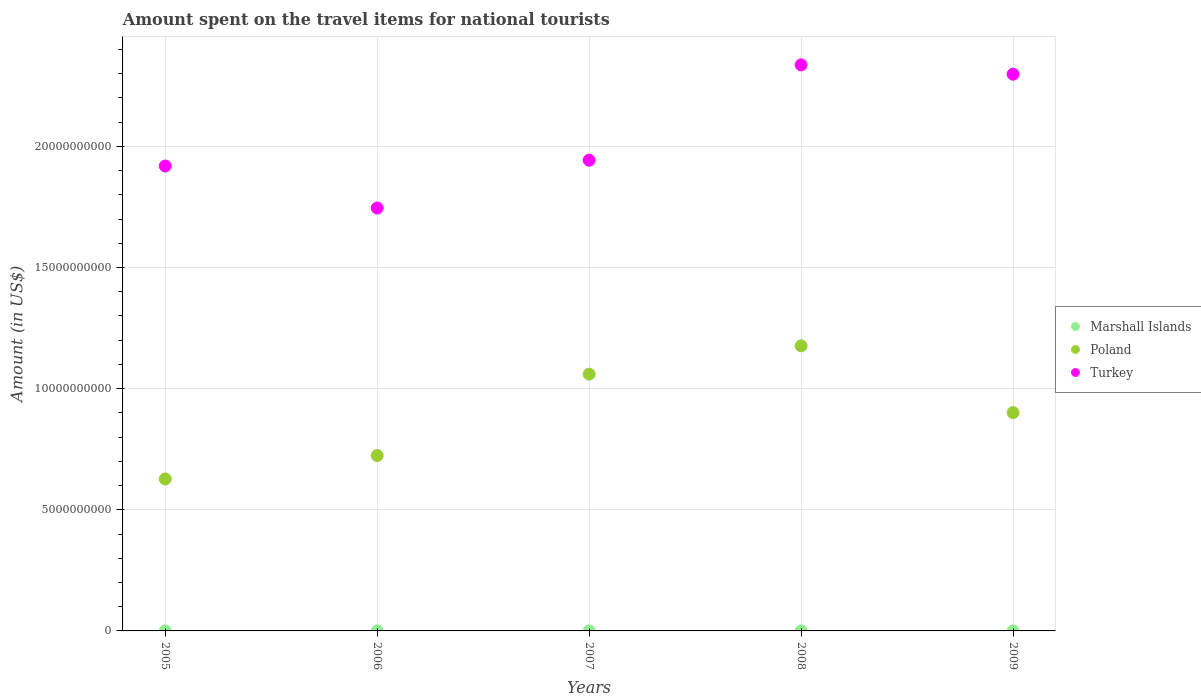How many different coloured dotlines are there?
Give a very brief answer. 3. Is the number of dotlines equal to the number of legend labels?
Make the answer very short. Yes. What is the amount spent on the travel items for national tourists in Marshall Islands in 2007?
Make the answer very short. 2.88e+06. Across all years, what is the maximum amount spent on the travel items for national tourists in Marshall Islands?
Offer a very short reply. 3.20e+06. Across all years, what is the minimum amount spent on the travel items for national tourists in Turkey?
Provide a succinct answer. 1.75e+1. What is the total amount spent on the travel items for national tourists in Turkey in the graph?
Provide a succinct answer. 1.02e+11. What is the difference between the amount spent on the travel items for national tourists in Poland in 2006 and that in 2009?
Offer a very short reply. -1.77e+09. What is the difference between the amount spent on the travel items for national tourists in Turkey in 2008 and the amount spent on the travel items for national tourists in Marshall Islands in 2009?
Provide a succinct answer. 2.34e+1. What is the average amount spent on the travel items for national tourists in Marshall Islands per year?
Keep it short and to the point. 2.94e+06. In the year 2008, what is the difference between the amount spent on the travel items for national tourists in Poland and amount spent on the travel items for national tourists in Turkey?
Offer a very short reply. -1.16e+1. In how many years, is the amount spent on the travel items for national tourists in Marshall Islands greater than 18000000000 US$?
Your answer should be compact. 0. What is the ratio of the amount spent on the travel items for national tourists in Poland in 2005 to that in 2008?
Offer a very short reply. 0.53. Is the amount spent on the travel items for national tourists in Poland in 2005 less than that in 2006?
Provide a short and direct response. Yes. What is the difference between the highest and the second highest amount spent on the travel items for national tourists in Marshall Islands?
Give a very brief answer. 1.00e+05. What is the difference between the highest and the lowest amount spent on the travel items for national tourists in Poland?
Provide a succinct answer. 5.49e+09. Does the amount spent on the travel items for national tourists in Marshall Islands monotonically increase over the years?
Keep it short and to the point. No. Is the amount spent on the travel items for national tourists in Marshall Islands strictly greater than the amount spent on the travel items for national tourists in Poland over the years?
Make the answer very short. No. What is the difference between two consecutive major ticks on the Y-axis?
Ensure brevity in your answer.  5.00e+09. Are the values on the major ticks of Y-axis written in scientific E-notation?
Make the answer very short. No. Does the graph contain any zero values?
Provide a short and direct response. No. Where does the legend appear in the graph?
Provide a succinct answer. Center right. How many legend labels are there?
Your answer should be compact. 3. How are the legend labels stacked?
Keep it short and to the point. Vertical. What is the title of the graph?
Ensure brevity in your answer.  Amount spent on the travel items for national tourists. What is the label or title of the Y-axis?
Your response must be concise. Amount (in US$). What is the Amount (in US$) of Marshall Islands in 2005?
Offer a very short reply. 3.20e+06. What is the Amount (in US$) in Poland in 2005?
Ensure brevity in your answer.  6.27e+09. What is the Amount (in US$) in Turkey in 2005?
Your answer should be very brief. 1.92e+1. What is the Amount (in US$) in Marshall Islands in 2006?
Make the answer very short. 3.10e+06. What is the Amount (in US$) in Poland in 2006?
Your response must be concise. 7.24e+09. What is the Amount (in US$) of Turkey in 2006?
Offer a very short reply. 1.75e+1. What is the Amount (in US$) in Marshall Islands in 2007?
Provide a succinct answer. 2.88e+06. What is the Amount (in US$) of Poland in 2007?
Keep it short and to the point. 1.06e+1. What is the Amount (in US$) of Turkey in 2007?
Your response must be concise. 1.94e+1. What is the Amount (in US$) of Marshall Islands in 2008?
Keep it short and to the point. 2.60e+06. What is the Amount (in US$) in Poland in 2008?
Offer a terse response. 1.18e+1. What is the Amount (in US$) in Turkey in 2008?
Offer a very short reply. 2.34e+1. What is the Amount (in US$) in Marshall Islands in 2009?
Offer a very short reply. 2.90e+06. What is the Amount (in US$) of Poland in 2009?
Provide a short and direct response. 9.01e+09. What is the Amount (in US$) of Turkey in 2009?
Your response must be concise. 2.30e+1. Across all years, what is the maximum Amount (in US$) of Marshall Islands?
Provide a succinct answer. 3.20e+06. Across all years, what is the maximum Amount (in US$) of Poland?
Your answer should be compact. 1.18e+1. Across all years, what is the maximum Amount (in US$) of Turkey?
Offer a very short reply. 2.34e+1. Across all years, what is the minimum Amount (in US$) of Marshall Islands?
Provide a succinct answer. 2.60e+06. Across all years, what is the minimum Amount (in US$) of Poland?
Your answer should be very brief. 6.27e+09. Across all years, what is the minimum Amount (in US$) of Turkey?
Provide a succinct answer. 1.75e+1. What is the total Amount (in US$) of Marshall Islands in the graph?
Provide a short and direct response. 1.47e+07. What is the total Amount (in US$) in Poland in the graph?
Make the answer very short. 4.49e+1. What is the total Amount (in US$) of Turkey in the graph?
Your answer should be compact. 1.02e+11. What is the difference between the Amount (in US$) of Poland in 2005 and that in 2006?
Your answer should be compact. -9.65e+08. What is the difference between the Amount (in US$) of Turkey in 2005 and that in 2006?
Provide a short and direct response. 1.73e+09. What is the difference between the Amount (in US$) in Marshall Islands in 2005 and that in 2007?
Keep it short and to the point. 3.20e+05. What is the difference between the Amount (in US$) of Poland in 2005 and that in 2007?
Your response must be concise. -4.32e+09. What is the difference between the Amount (in US$) of Turkey in 2005 and that in 2007?
Provide a short and direct response. -2.39e+08. What is the difference between the Amount (in US$) of Poland in 2005 and that in 2008?
Ensure brevity in your answer.  -5.49e+09. What is the difference between the Amount (in US$) in Turkey in 2005 and that in 2008?
Provide a short and direct response. -4.17e+09. What is the difference between the Amount (in US$) in Poland in 2005 and that in 2009?
Provide a succinct answer. -2.74e+09. What is the difference between the Amount (in US$) in Turkey in 2005 and that in 2009?
Offer a terse response. -3.79e+09. What is the difference between the Amount (in US$) in Poland in 2006 and that in 2007?
Ensure brevity in your answer.  -3.36e+09. What is the difference between the Amount (in US$) of Turkey in 2006 and that in 2007?
Keep it short and to the point. -1.97e+09. What is the difference between the Amount (in US$) of Poland in 2006 and that in 2008?
Offer a terse response. -4.53e+09. What is the difference between the Amount (in US$) of Turkey in 2006 and that in 2008?
Provide a short and direct response. -5.91e+09. What is the difference between the Amount (in US$) in Poland in 2006 and that in 2009?
Provide a short and direct response. -1.77e+09. What is the difference between the Amount (in US$) of Turkey in 2006 and that in 2009?
Ensure brevity in your answer.  -5.52e+09. What is the difference between the Amount (in US$) of Poland in 2007 and that in 2008?
Make the answer very short. -1.17e+09. What is the difference between the Amount (in US$) of Turkey in 2007 and that in 2008?
Your answer should be very brief. -3.94e+09. What is the difference between the Amount (in US$) of Poland in 2007 and that in 2009?
Provide a succinct answer. 1.59e+09. What is the difference between the Amount (in US$) in Turkey in 2007 and that in 2009?
Offer a very short reply. -3.55e+09. What is the difference between the Amount (in US$) in Poland in 2008 and that in 2009?
Make the answer very short. 2.76e+09. What is the difference between the Amount (in US$) in Turkey in 2008 and that in 2009?
Ensure brevity in your answer.  3.85e+08. What is the difference between the Amount (in US$) in Marshall Islands in 2005 and the Amount (in US$) in Poland in 2006?
Provide a succinct answer. -7.24e+09. What is the difference between the Amount (in US$) of Marshall Islands in 2005 and the Amount (in US$) of Turkey in 2006?
Provide a short and direct response. -1.75e+1. What is the difference between the Amount (in US$) of Poland in 2005 and the Amount (in US$) of Turkey in 2006?
Ensure brevity in your answer.  -1.12e+1. What is the difference between the Amount (in US$) in Marshall Islands in 2005 and the Amount (in US$) in Poland in 2007?
Give a very brief answer. -1.06e+1. What is the difference between the Amount (in US$) of Marshall Islands in 2005 and the Amount (in US$) of Turkey in 2007?
Offer a very short reply. -1.94e+1. What is the difference between the Amount (in US$) of Poland in 2005 and the Amount (in US$) of Turkey in 2007?
Keep it short and to the point. -1.32e+1. What is the difference between the Amount (in US$) of Marshall Islands in 2005 and the Amount (in US$) of Poland in 2008?
Offer a very short reply. -1.18e+1. What is the difference between the Amount (in US$) of Marshall Islands in 2005 and the Amount (in US$) of Turkey in 2008?
Provide a short and direct response. -2.34e+1. What is the difference between the Amount (in US$) in Poland in 2005 and the Amount (in US$) in Turkey in 2008?
Give a very brief answer. -1.71e+1. What is the difference between the Amount (in US$) of Marshall Islands in 2005 and the Amount (in US$) of Poland in 2009?
Make the answer very short. -9.01e+09. What is the difference between the Amount (in US$) in Marshall Islands in 2005 and the Amount (in US$) in Turkey in 2009?
Provide a short and direct response. -2.30e+1. What is the difference between the Amount (in US$) in Poland in 2005 and the Amount (in US$) in Turkey in 2009?
Keep it short and to the point. -1.67e+1. What is the difference between the Amount (in US$) of Marshall Islands in 2006 and the Amount (in US$) of Poland in 2007?
Your answer should be compact. -1.06e+1. What is the difference between the Amount (in US$) of Marshall Islands in 2006 and the Amount (in US$) of Turkey in 2007?
Provide a short and direct response. -1.94e+1. What is the difference between the Amount (in US$) in Poland in 2006 and the Amount (in US$) in Turkey in 2007?
Give a very brief answer. -1.22e+1. What is the difference between the Amount (in US$) in Marshall Islands in 2006 and the Amount (in US$) in Poland in 2008?
Provide a short and direct response. -1.18e+1. What is the difference between the Amount (in US$) in Marshall Islands in 2006 and the Amount (in US$) in Turkey in 2008?
Provide a short and direct response. -2.34e+1. What is the difference between the Amount (in US$) of Poland in 2006 and the Amount (in US$) of Turkey in 2008?
Offer a terse response. -1.61e+1. What is the difference between the Amount (in US$) in Marshall Islands in 2006 and the Amount (in US$) in Poland in 2009?
Your answer should be very brief. -9.01e+09. What is the difference between the Amount (in US$) of Marshall Islands in 2006 and the Amount (in US$) of Turkey in 2009?
Keep it short and to the point. -2.30e+1. What is the difference between the Amount (in US$) in Poland in 2006 and the Amount (in US$) in Turkey in 2009?
Your answer should be compact. -1.57e+1. What is the difference between the Amount (in US$) in Marshall Islands in 2007 and the Amount (in US$) in Poland in 2008?
Offer a terse response. -1.18e+1. What is the difference between the Amount (in US$) of Marshall Islands in 2007 and the Amount (in US$) of Turkey in 2008?
Provide a succinct answer. -2.34e+1. What is the difference between the Amount (in US$) in Poland in 2007 and the Amount (in US$) in Turkey in 2008?
Your answer should be compact. -1.28e+1. What is the difference between the Amount (in US$) of Marshall Islands in 2007 and the Amount (in US$) of Poland in 2009?
Offer a very short reply. -9.01e+09. What is the difference between the Amount (in US$) in Marshall Islands in 2007 and the Amount (in US$) in Turkey in 2009?
Give a very brief answer. -2.30e+1. What is the difference between the Amount (in US$) of Poland in 2007 and the Amount (in US$) of Turkey in 2009?
Your answer should be very brief. -1.24e+1. What is the difference between the Amount (in US$) in Marshall Islands in 2008 and the Amount (in US$) in Poland in 2009?
Offer a terse response. -9.01e+09. What is the difference between the Amount (in US$) of Marshall Islands in 2008 and the Amount (in US$) of Turkey in 2009?
Offer a terse response. -2.30e+1. What is the difference between the Amount (in US$) of Poland in 2008 and the Amount (in US$) of Turkey in 2009?
Ensure brevity in your answer.  -1.12e+1. What is the average Amount (in US$) of Marshall Islands per year?
Provide a succinct answer. 2.94e+06. What is the average Amount (in US$) in Poland per year?
Offer a terse response. 8.98e+09. What is the average Amount (in US$) in Turkey per year?
Your response must be concise. 2.05e+1. In the year 2005, what is the difference between the Amount (in US$) in Marshall Islands and Amount (in US$) in Poland?
Offer a very short reply. -6.27e+09. In the year 2005, what is the difference between the Amount (in US$) in Marshall Islands and Amount (in US$) in Turkey?
Provide a short and direct response. -1.92e+1. In the year 2005, what is the difference between the Amount (in US$) in Poland and Amount (in US$) in Turkey?
Keep it short and to the point. -1.29e+1. In the year 2006, what is the difference between the Amount (in US$) of Marshall Islands and Amount (in US$) of Poland?
Your response must be concise. -7.24e+09. In the year 2006, what is the difference between the Amount (in US$) of Marshall Islands and Amount (in US$) of Turkey?
Ensure brevity in your answer.  -1.75e+1. In the year 2006, what is the difference between the Amount (in US$) in Poland and Amount (in US$) in Turkey?
Offer a very short reply. -1.02e+1. In the year 2007, what is the difference between the Amount (in US$) of Marshall Islands and Amount (in US$) of Poland?
Offer a very short reply. -1.06e+1. In the year 2007, what is the difference between the Amount (in US$) of Marshall Islands and Amount (in US$) of Turkey?
Provide a short and direct response. -1.94e+1. In the year 2007, what is the difference between the Amount (in US$) in Poland and Amount (in US$) in Turkey?
Keep it short and to the point. -8.83e+09. In the year 2008, what is the difference between the Amount (in US$) of Marshall Islands and Amount (in US$) of Poland?
Make the answer very short. -1.18e+1. In the year 2008, what is the difference between the Amount (in US$) in Marshall Islands and Amount (in US$) in Turkey?
Your response must be concise. -2.34e+1. In the year 2008, what is the difference between the Amount (in US$) in Poland and Amount (in US$) in Turkey?
Your response must be concise. -1.16e+1. In the year 2009, what is the difference between the Amount (in US$) of Marshall Islands and Amount (in US$) of Poland?
Provide a short and direct response. -9.01e+09. In the year 2009, what is the difference between the Amount (in US$) of Marshall Islands and Amount (in US$) of Turkey?
Provide a short and direct response. -2.30e+1. In the year 2009, what is the difference between the Amount (in US$) in Poland and Amount (in US$) in Turkey?
Give a very brief answer. -1.40e+1. What is the ratio of the Amount (in US$) in Marshall Islands in 2005 to that in 2006?
Offer a very short reply. 1.03. What is the ratio of the Amount (in US$) of Poland in 2005 to that in 2006?
Offer a terse response. 0.87. What is the ratio of the Amount (in US$) in Turkey in 2005 to that in 2006?
Ensure brevity in your answer.  1.1. What is the ratio of the Amount (in US$) in Poland in 2005 to that in 2007?
Your answer should be compact. 0.59. What is the ratio of the Amount (in US$) of Turkey in 2005 to that in 2007?
Keep it short and to the point. 0.99. What is the ratio of the Amount (in US$) of Marshall Islands in 2005 to that in 2008?
Provide a short and direct response. 1.23. What is the ratio of the Amount (in US$) in Poland in 2005 to that in 2008?
Your answer should be very brief. 0.53. What is the ratio of the Amount (in US$) in Turkey in 2005 to that in 2008?
Provide a succinct answer. 0.82. What is the ratio of the Amount (in US$) in Marshall Islands in 2005 to that in 2009?
Provide a short and direct response. 1.1. What is the ratio of the Amount (in US$) of Poland in 2005 to that in 2009?
Offer a very short reply. 0.7. What is the ratio of the Amount (in US$) in Turkey in 2005 to that in 2009?
Ensure brevity in your answer.  0.84. What is the ratio of the Amount (in US$) of Marshall Islands in 2006 to that in 2007?
Provide a succinct answer. 1.08. What is the ratio of the Amount (in US$) in Poland in 2006 to that in 2007?
Offer a terse response. 0.68. What is the ratio of the Amount (in US$) in Turkey in 2006 to that in 2007?
Keep it short and to the point. 0.9. What is the ratio of the Amount (in US$) in Marshall Islands in 2006 to that in 2008?
Keep it short and to the point. 1.19. What is the ratio of the Amount (in US$) of Poland in 2006 to that in 2008?
Ensure brevity in your answer.  0.62. What is the ratio of the Amount (in US$) in Turkey in 2006 to that in 2008?
Offer a terse response. 0.75. What is the ratio of the Amount (in US$) of Marshall Islands in 2006 to that in 2009?
Keep it short and to the point. 1.07. What is the ratio of the Amount (in US$) of Poland in 2006 to that in 2009?
Your answer should be compact. 0.8. What is the ratio of the Amount (in US$) in Turkey in 2006 to that in 2009?
Keep it short and to the point. 0.76. What is the ratio of the Amount (in US$) in Marshall Islands in 2007 to that in 2008?
Provide a succinct answer. 1.11. What is the ratio of the Amount (in US$) in Poland in 2007 to that in 2008?
Your response must be concise. 0.9. What is the ratio of the Amount (in US$) in Turkey in 2007 to that in 2008?
Offer a very short reply. 0.83. What is the ratio of the Amount (in US$) in Marshall Islands in 2007 to that in 2009?
Offer a very short reply. 0.99. What is the ratio of the Amount (in US$) of Poland in 2007 to that in 2009?
Provide a succinct answer. 1.18. What is the ratio of the Amount (in US$) of Turkey in 2007 to that in 2009?
Offer a terse response. 0.85. What is the ratio of the Amount (in US$) of Marshall Islands in 2008 to that in 2009?
Give a very brief answer. 0.9. What is the ratio of the Amount (in US$) in Poland in 2008 to that in 2009?
Offer a very short reply. 1.31. What is the ratio of the Amount (in US$) of Turkey in 2008 to that in 2009?
Your response must be concise. 1.02. What is the difference between the highest and the second highest Amount (in US$) of Marshall Islands?
Your answer should be very brief. 1.00e+05. What is the difference between the highest and the second highest Amount (in US$) in Poland?
Your answer should be very brief. 1.17e+09. What is the difference between the highest and the second highest Amount (in US$) of Turkey?
Your response must be concise. 3.85e+08. What is the difference between the highest and the lowest Amount (in US$) in Poland?
Your answer should be very brief. 5.49e+09. What is the difference between the highest and the lowest Amount (in US$) of Turkey?
Provide a succinct answer. 5.91e+09. 